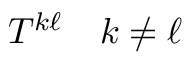Convert formula to latex. <formula><loc_0><loc_0><loc_500><loc_500>T ^ { k \ell } \quad k \neq \ell</formula> 